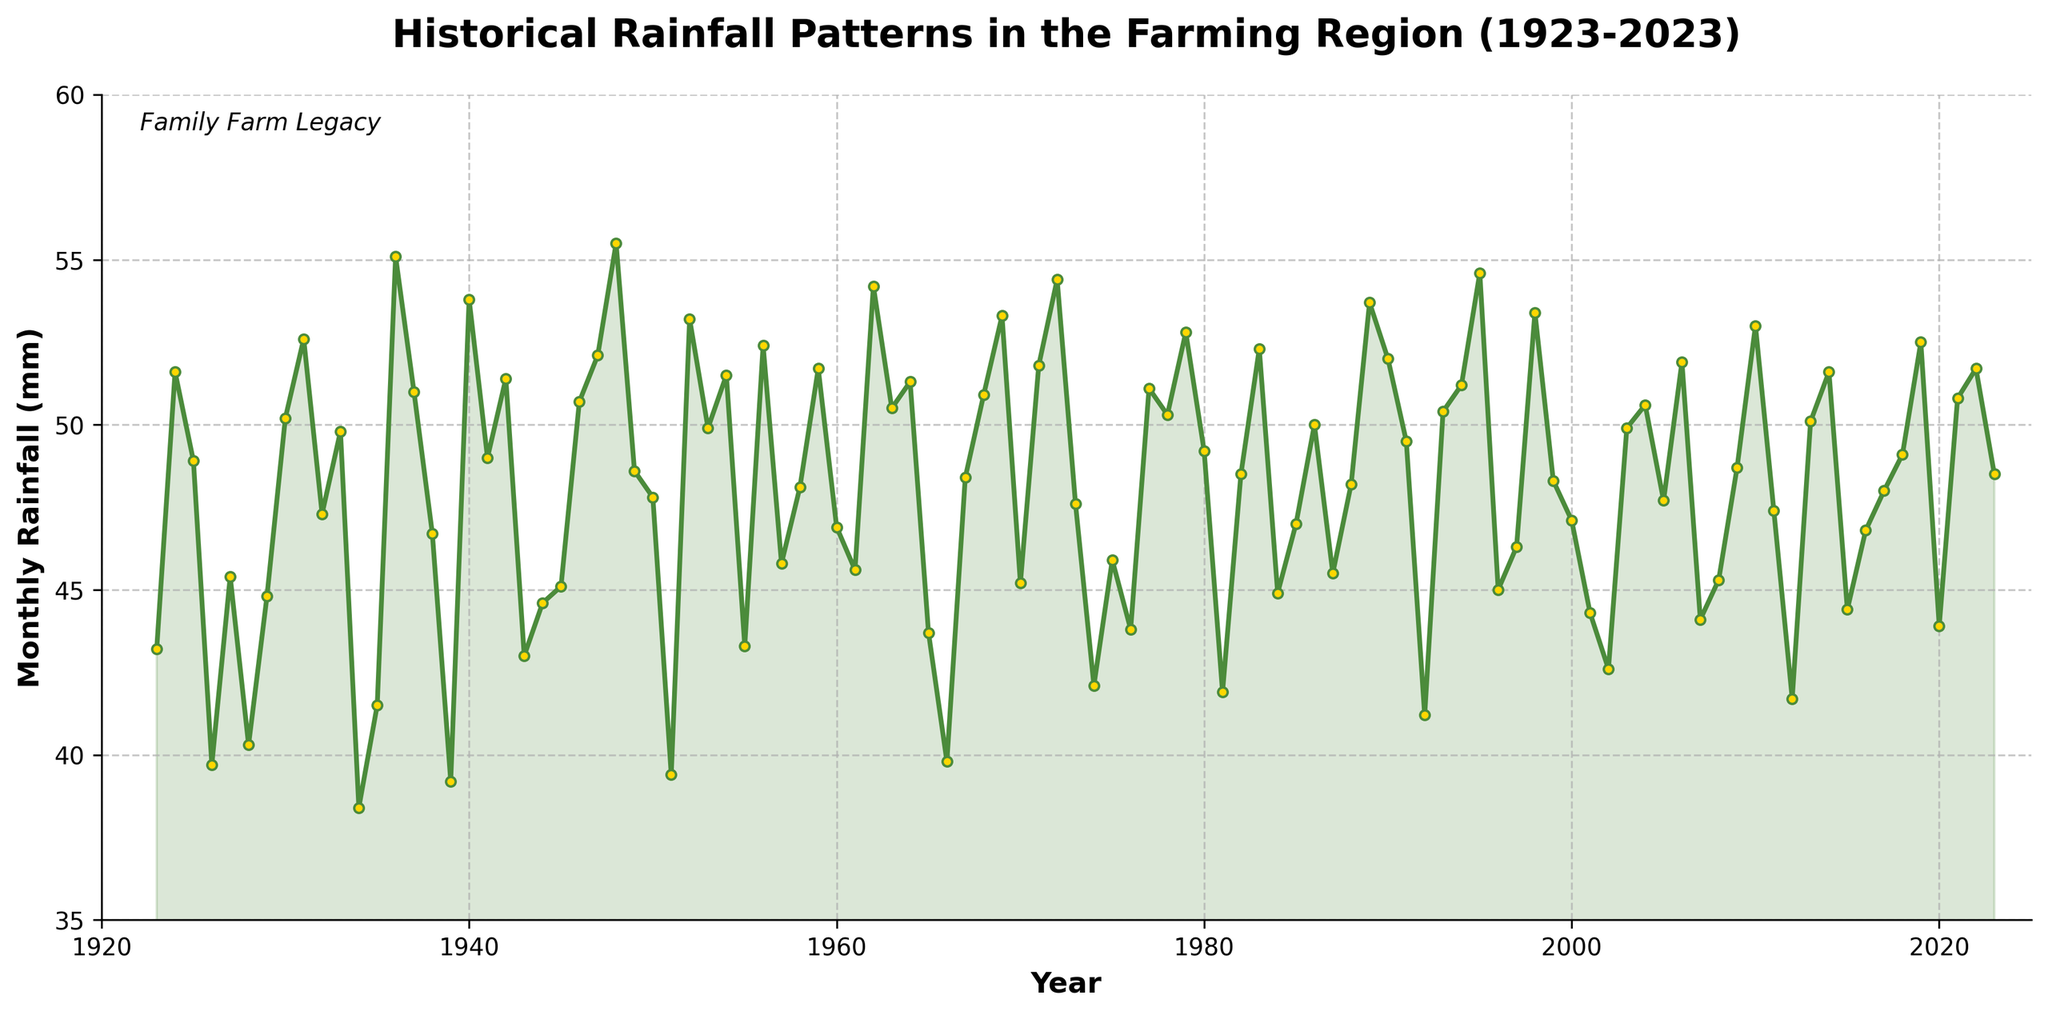What is the title of the plot? The title is generally located at the top center of the plot. It summarizes the main insight the plot aims to convey. Here, the title reads "Historical Rainfall Patterns in the Farming Region (1923-2023)"
Answer: Historical Rainfall Patterns in the Farming Region (1923-2023) What are the labels of the axes? The labels of the axes provide information about what each axis represents. The x-axis is labeled 'Year' and the y-axis is labeled 'Monthly Rainfall (mm)'.
Answer: x-axis: Year, y-axis: Monthly Rainfall (mm) How many data points are there in the plot? The data points correspond to each year from 1923 to 2023. To find the total number, we simply count these points. Since the plot covers 1923 to 2023, there are 101 data points.
Answer: 101 What year had the lowest monthly rainfall and how much was it? The year with the lowest monthly rainfall can be found by looking for the smallest value on the y-axis and tracing it to the corresponding year on the x-axis. The lowest value appears to be around 38.4 mm in 1934.
Answer: 1934, 38.4 mm Compare the monthly rainfall in 1925 and 2015. Which year had more rainfall? To compare the rainfall of two specific years, we locate the data points for those years and compare their y-axis values. In 1925, the rainfall was 48.9 mm, while in 2015 it was 44.4 mm. Therefore, 1925 had more rainfall.
Answer: 1925 What is the average monthly rainfall over the 100 years? To find the average rainfall, sum all the monthly rainfall values and divide by the number of years. Sum is approximately 4972.2 mm, and dividing by 101 gives an average of roughly 49.2 mm.
Answer: 49.2 mm During which decade did the region experience the most consistent monthly rainfall? To determine consistency, we examine the decade with the least variability (smallest range between highest and lowest values). This appears to be the 1960s, as the values hover closely around the 50 mm mark.
Answer: 1960s What trend can be observed in the rainfall pattern between the first and last 20 years? To observe trends, look at the general incline or decline in the rainfall data points over the given periods. From the first 20 years, the rainfall fluctuates but remains around mid-40s mm. In the last 20 years, the rainfall appears more stable around 50 mm.
Answer: Increased stability How does the monthly rainfall in 1975 compare to the average monthly rainfall? Calculate the deviation by subtracting the average monthly rainfall (49.2 mm) from the rainfall in 1975 (45.9 mm). The deviation is -3.3 mm, meaning 1975 had less rainfall than the average.
Answer: 3.3 mm less Is there a noticeable trend in rainfall over the entire period? Trend analysis involves identifying whether the rainfall generally increases, decreases, or remains stable. Observing the plot, there is no consistent upward or downward trend; rather, the rainfall shows fluctuations but averages around 49-50 mm over the century.
Answer: No consistent trend 